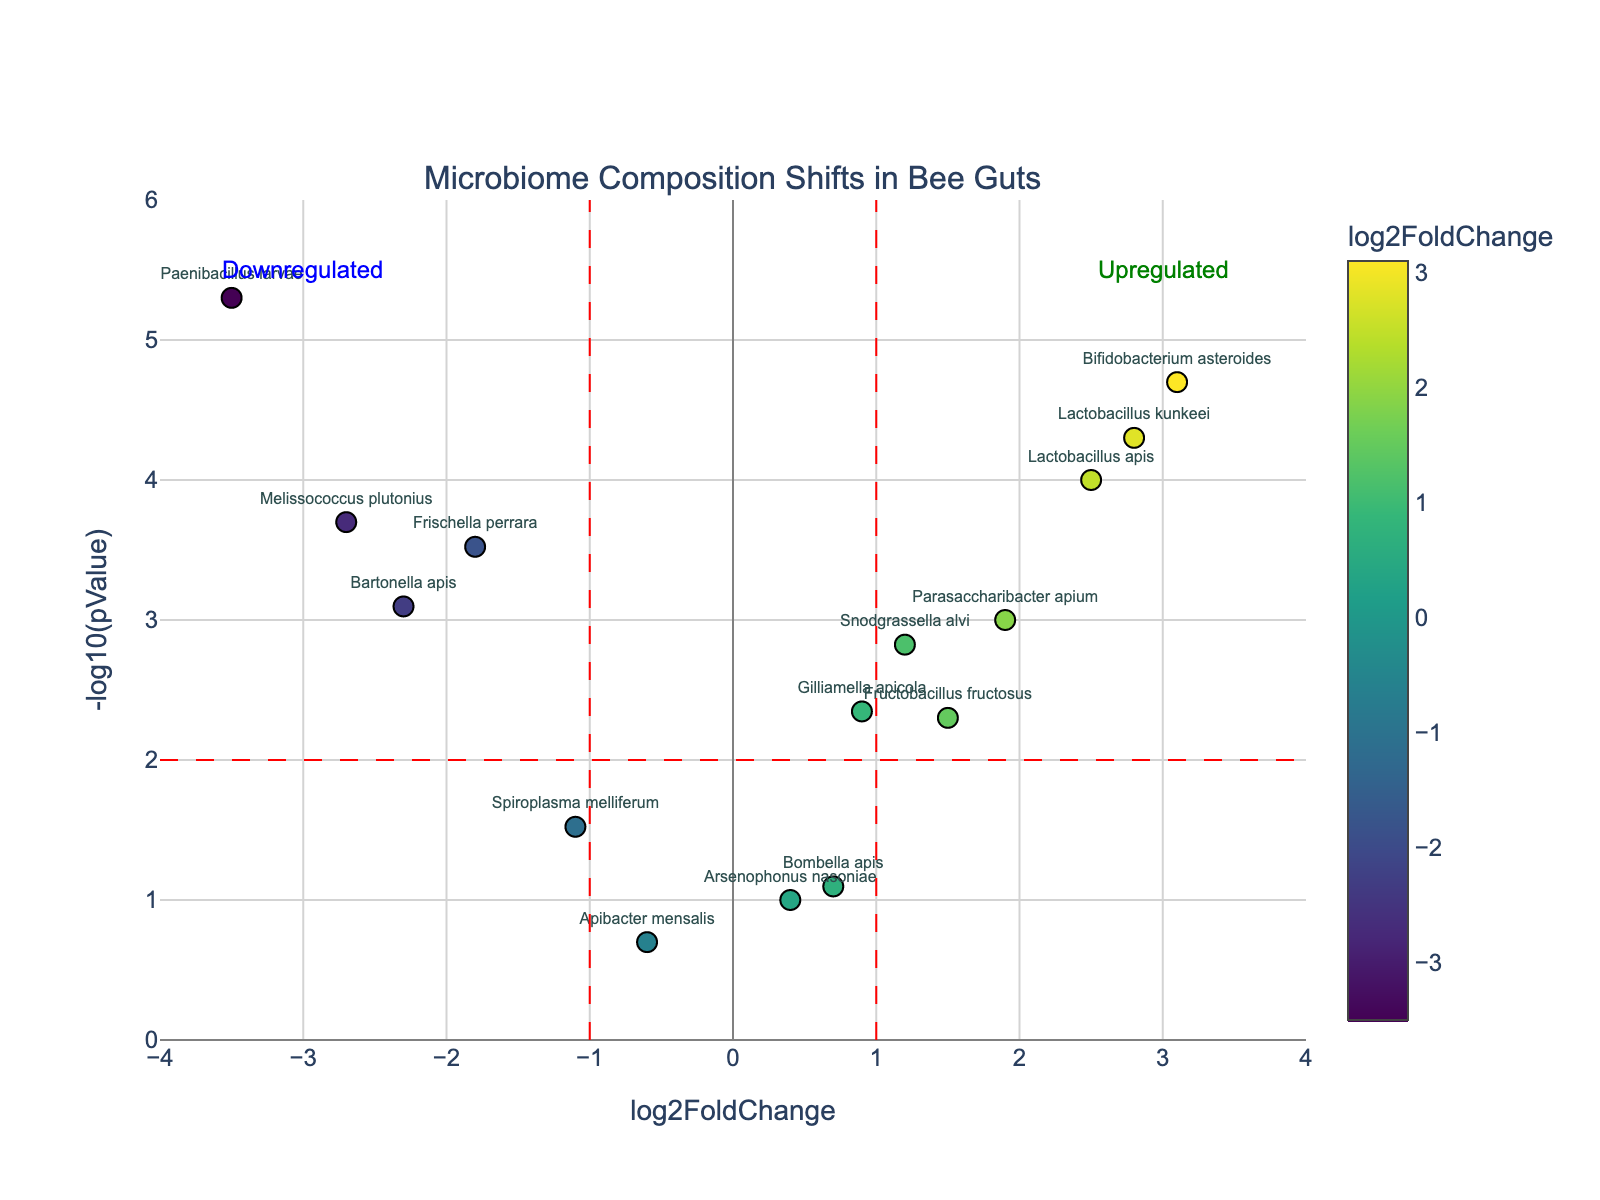What does the X-axis represent in the volcano plot? The X-axis represents the log2FoldChange, which indicates the magnitude of change in the abundance of specific bacteria after probiotic treatment, with positive values indicating upregulation and negative values indicating downregulation.
Answer: log2FoldChange What is the title of the plot? The title of the plot is displayed at the top of the figure and reads "Microbiome Composition Shifts in Bee Guts".
Answer: Microbiome Composition Shifts in Bee Guts How many bacteria are significantly upregulated? To determine the number of significantly upregulated bacteria, look for data points with a log2FoldChange greater than 1 and a -log10(pValue) greater than 2. Based on the data, these points include Lactobacillus apis, Bifidobacterium asteroides, Lactobacillus kunkeei, and Parasaccharibacter apium.
Answer: 4 Which bacterium is the most significantly downregulated? Find the bacterium with the most negative log2FoldChange and a high -log10(pValue). Paenibacillus larvae has the lowest log2FoldChange of -3.5 and a highly significant p-value (high -log10(pValue)).
Answer: Paenibacillus larvae Which bacterium has the highest log2FoldChange? Observe the plot to find the bacterium with the highest positive log2FoldChange. Bifidobacterium asteroides has the highest log2FoldChange of 3.1.
Answer: Bifidobacterium asteroides How many data points are in the plot? Count each data point in the dataset or plot. Each bacterium represents one data point, totaling 14 in the plot based on the given data.
Answer: 14 Which bacteria represent beneficial bacteria that were significantly upregulated? Identify bacteria known to be beneficial and check if their log2FoldChange is greater than 1 and -log10(pValue) is significant. Lactobacillus apis, Bifidobacterium asteroides, and Lactobacillus kunkeei fit this criteria.
Answer: Lactobacillus apis, Bifidobacterium asteroides, Lactobacillus kunkeei What is the range of -log10(pValue) values shown in the plot? Examine the y-axis to determine the range of -log10(pValue). The plot ranges from 0 to 6, representing the transformation of p-values to emphasize significant differences.
Answer: 0 to 6 Identify any bacteria that have a log2FoldChange close to zero. Look for bacteria with log2FoldChange near 0. Arsenophonus nasoniae and Apibacter mensalis have log2FoldChanges of 0.4 and -0.6, respectively.
Answer: Arsenophonus nasoniae, Apibacter mensalis What threshold is used to define significant change in the plot? The plot uses threshold lines at log2FoldChange of +1 and -1 for upregulation and downregulation, and a -log10(pValue) of 2 to indicate significance.
Answer: log2FoldChange of ±1 and -log10(pValue) of 2 